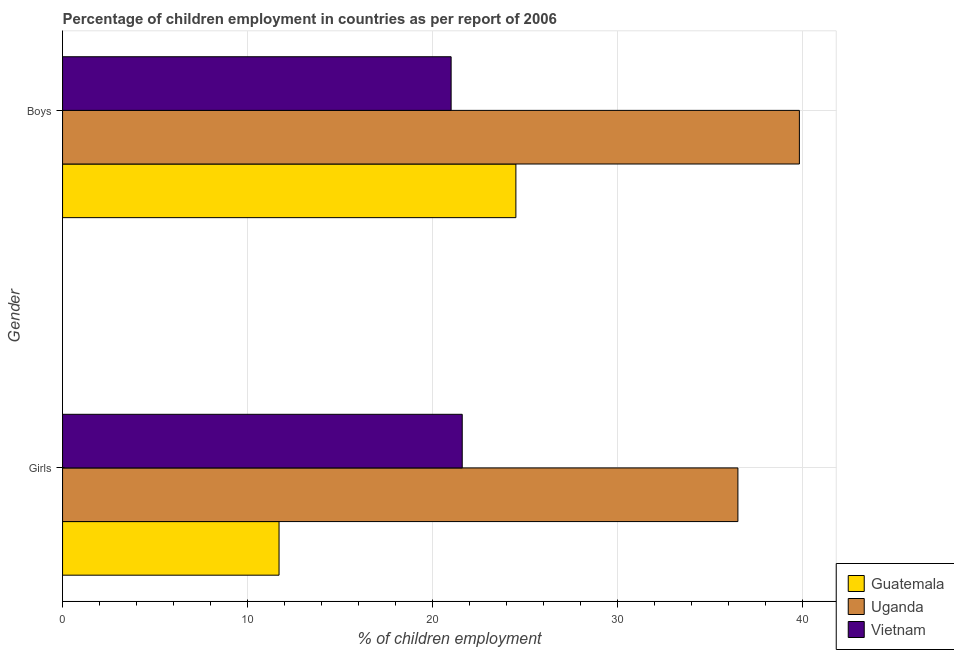How many different coloured bars are there?
Make the answer very short. 3. How many bars are there on the 1st tick from the top?
Provide a succinct answer. 3. What is the label of the 2nd group of bars from the top?
Provide a short and direct response. Girls. Across all countries, what is the maximum percentage of employed boys?
Offer a terse response. 39.82. Across all countries, what is the minimum percentage of employed girls?
Your answer should be compact. 11.7. In which country was the percentage of employed girls maximum?
Your answer should be compact. Uganda. In which country was the percentage of employed girls minimum?
Keep it short and to the point. Guatemala. What is the total percentage of employed girls in the graph?
Give a very brief answer. 69.8. What is the difference between the percentage of employed boys in Uganda and that in Vietnam?
Give a very brief answer. 18.82. What is the difference between the percentage of employed girls in Uganda and the percentage of employed boys in Vietnam?
Provide a succinct answer. 15.5. What is the average percentage of employed boys per country?
Keep it short and to the point. 28.44. What is the difference between the percentage of employed girls and percentage of employed boys in Vietnam?
Keep it short and to the point. 0.6. What is the ratio of the percentage of employed boys in Uganda to that in Guatemala?
Make the answer very short. 1.63. In how many countries, is the percentage of employed boys greater than the average percentage of employed boys taken over all countries?
Provide a short and direct response. 1. What does the 2nd bar from the top in Boys represents?
Your answer should be compact. Uganda. What does the 3rd bar from the bottom in Girls represents?
Provide a succinct answer. Vietnam. How many bars are there?
Give a very brief answer. 6. Are all the bars in the graph horizontal?
Offer a very short reply. Yes. How many countries are there in the graph?
Give a very brief answer. 3. Does the graph contain any zero values?
Keep it short and to the point. No. Does the graph contain grids?
Your response must be concise. Yes. Where does the legend appear in the graph?
Give a very brief answer. Bottom right. How many legend labels are there?
Keep it short and to the point. 3. What is the title of the graph?
Your answer should be very brief. Percentage of children employment in countries as per report of 2006. Does "Bolivia" appear as one of the legend labels in the graph?
Give a very brief answer. No. What is the label or title of the X-axis?
Provide a succinct answer. % of children employment. What is the % of children employment in Uganda in Girls?
Make the answer very short. 36.5. What is the % of children employment in Vietnam in Girls?
Your answer should be compact. 21.6. What is the % of children employment of Guatemala in Boys?
Provide a short and direct response. 24.5. What is the % of children employment in Uganda in Boys?
Offer a very short reply. 39.82. What is the % of children employment in Vietnam in Boys?
Give a very brief answer. 21. Across all Gender, what is the maximum % of children employment in Guatemala?
Your response must be concise. 24.5. Across all Gender, what is the maximum % of children employment in Uganda?
Provide a succinct answer. 39.82. Across all Gender, what is the maximum % of children employment in Vietnam?
Keep it short and to the point. 21.6. Across all Gender, what is the minimum % of children employment of Guatemala?
Provide a short and direct response. 11.7. Across all Gender, what is the minimum % of children employment of Uganda?
Ensure brevity in your answer.  36.5. What is the total % of children employment of Guatemala in the graph?
Give a very brief answer. 36.2. What is the total % of children employment in Uganda in the graph?
Your answer should be very brief. 76.32. What is the total % of children employment of Vietnam in the graph?
Your answer should be very brief. 42.6. What is the difference between the % of children employment in Uganda in Girls and that in Boys?
Give a very brief answer. -3.32. What is the difference between the % of children employment of Vietnam in Girls and that in Boys?
Provide a short and direct response. 0.6. What is the difference between the % of children employment in Guatemala in Girls and the % of children employment in Uganda in Boys?
Provide a succinct answer. -28.12. What is the difference between the % of children employment in Uganda in Girls and the % of children employment in Vietnam in Boys?
Offer a terse response. 15.5. What is the average % of children employment in Guatemala per Gender?
Provide a succinct answer. 18.1. What is the average % of children employment of Uganda per Gender?
Your answer should be very brief. 38.16. What is the average % of children employment of Vietnam per Gender?
Keep it short and to the point. 21.3. What is the difference between the % of children employment in Guatemala and % of children employment in Uganda in Girls?
Provide a succinct answer. -24.8. What is the difference between the % of children employment in Uganda and % of children employment in Vietnam in Girls?
Your response must be concise. 14.9. What is the difference between the % of children employment of Guatemala and % of children employment of Uganda in Boys?
Keep it short and to the point. -15.32. What is the difference between the % of children employment of Guatemala and % of children employment of Vietnam in Boys?
Offer a very short reply. 3.5. What is the difference between the % of children employment of Uganda and % of children employment of Vietnam in Boys?
Your answer should be very brief. 18.82. What is the ratio of the % of children employment of Guatemala in Girls to that in Boys?
Your response must be concise. 0.48. What is the ratio of the % of children employment in Uganda in Girls to that in Boys?
Offer a very short reply. 0.92. What is the ratio of the % of children employment of Vietnam in Girls to that in Boys?
Your answer should be very brief. 1.03. What is the difference between the highest and the second highest % of children employment of Guatemala?
Ensure brevity in your answer.  12.8. What is the difference between the highest and the second highest % of children employment of Uganda?
Keep it short and to the point. 3.32. What is the difference between the highest and the second highest % of children employment of Vietnam?
Give a very brief answer. 0.6. What is the difference between the highest and the lowest % of children employment in Guatemala?
Your response must be concise. 12.8. What is the difference between the highest and the lowest % of children employment of Uganda?
Ensure brevity in your answer.  3.32. 